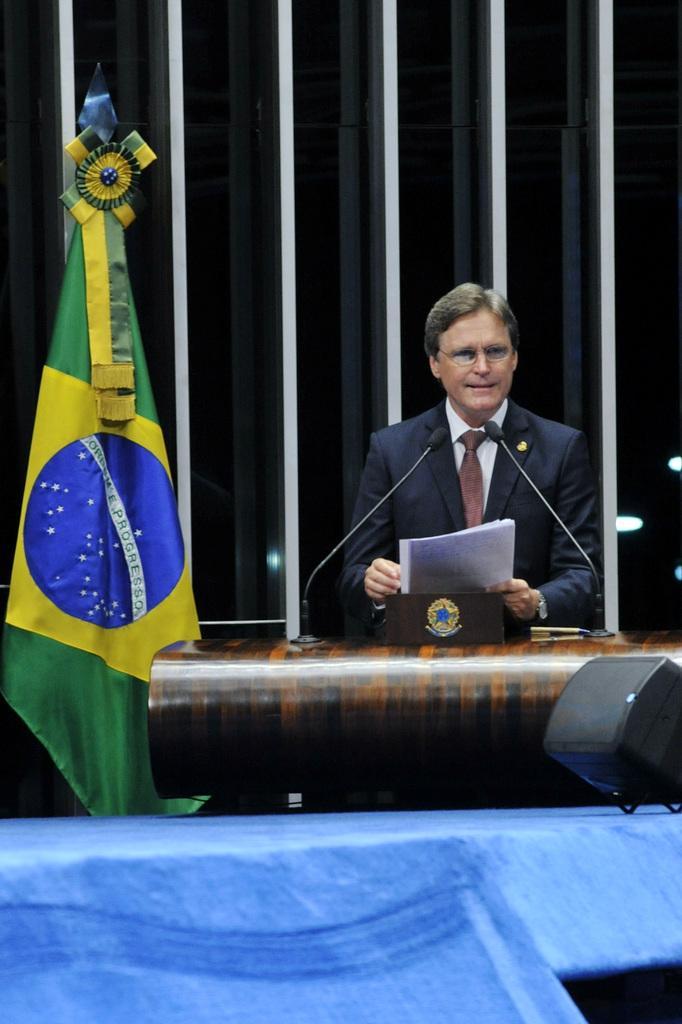Describe this image in one or two sentences. In this image there is a person holding papers in his hand, In front of the person there is a table with two mics, beside him there is a flag. On the bottom right side there is an object. In the background there is a wall. 